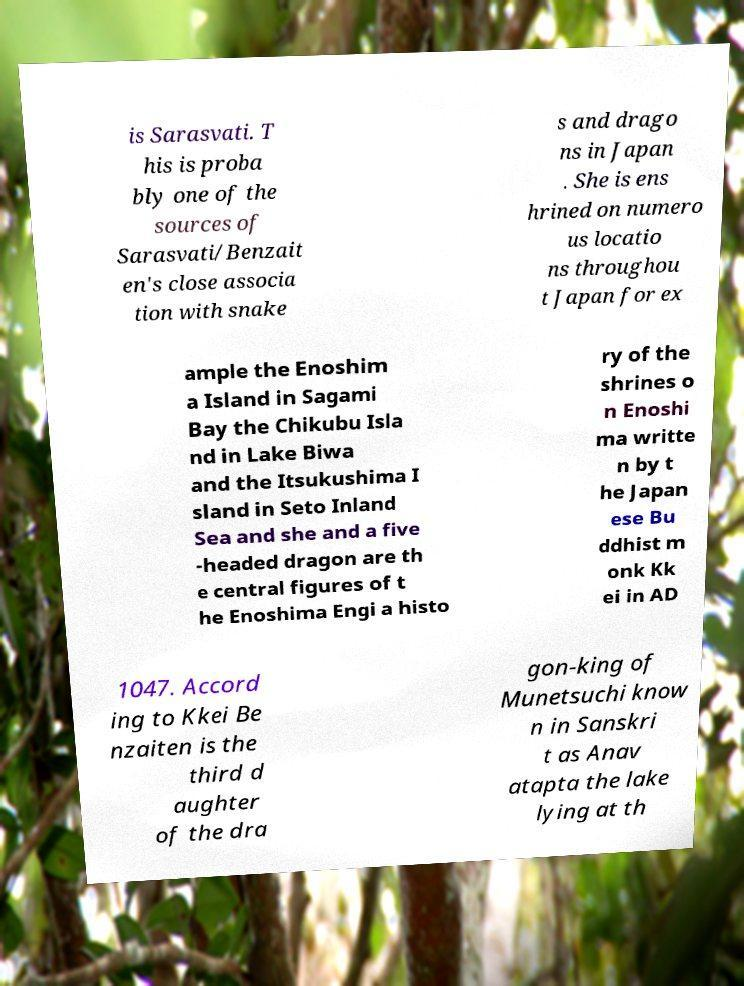Could you assist in decoding the text presented in this image and type it out clearly? is Sarasvati. T his is proba bly one of the sources of Sarasvati/Benzait en's close associa tion with snake s and drago ns in Japan . She is ens hrined on numero us locatio ns throughou t Japan for ex ample the Enoshim a Island in Sagami Bay the Chikubu Isla nd in Lake Biwa and the Itsukushima I sland in Seto Inland Sea and she and a five -headed dragon are th e central figures of t he Enoshima Engi a histo ry of the shrines o n Enoshi ma writte n by t he Japan ese Bu ddhist m onk Kk ei in AD 1047. Accord ing to Kkei Be nzaiten is the third d aughter of the dra gon-king of Munetsuchi know n in Sanskri t as Anav atapta the lake lying at th 